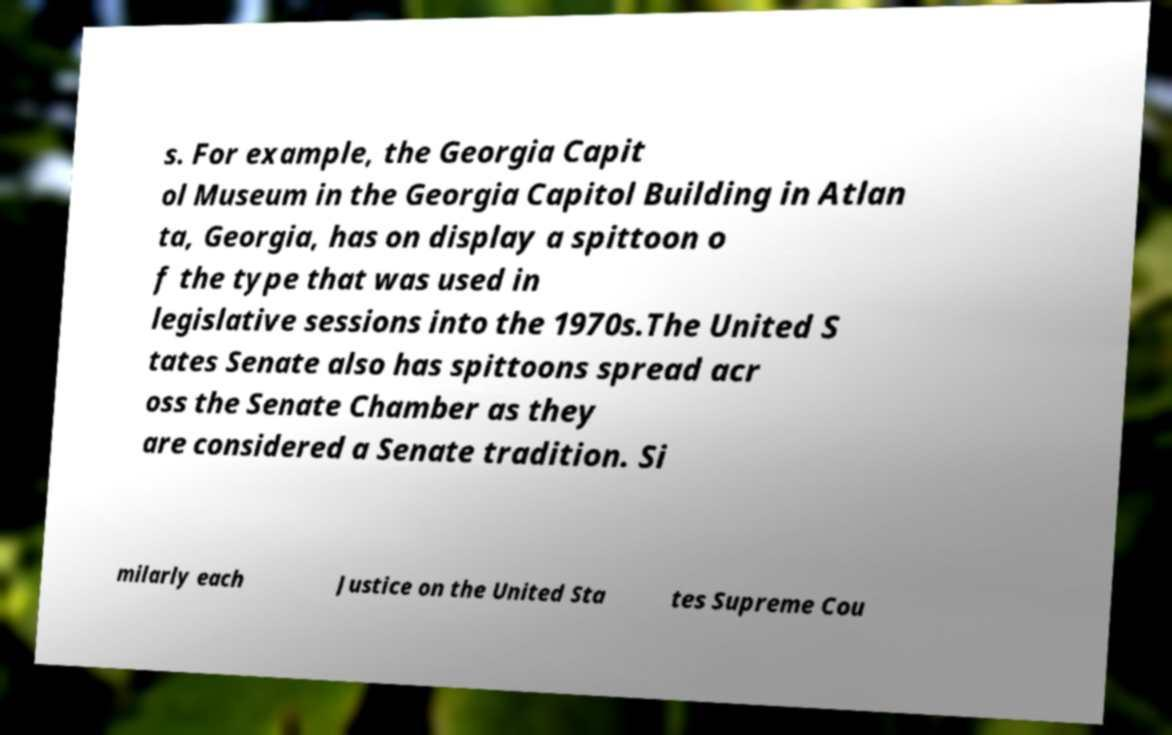Please identify and transcribe the text found in this image. s. For example, the Georgia Capit ol Museum in the Georgia Capitol Building in Atlan ta, Georgia, has on display a spittoon o f the type that was used in legislative sessions into the 1970s.The United S tates Senate also has spittoons spread acr oss the Senate Chamber as they are considered a Senate tradition. Si milarly each Justice on the United Sta tes Supreme Cou 